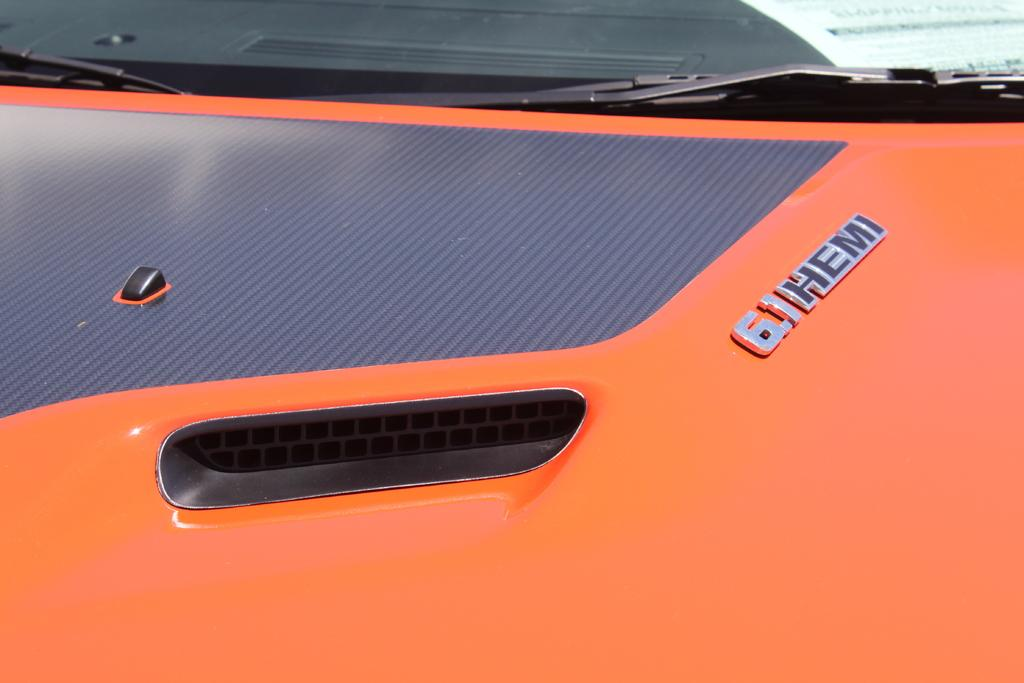What is the main subject of the image? There is a vehicle in the image. Can you describe the color of the vehicle? The vehicle is orange in color. What type of club is the vehicle a member of in the image? There is no indication in the image that the vehicle is a member of any club. 